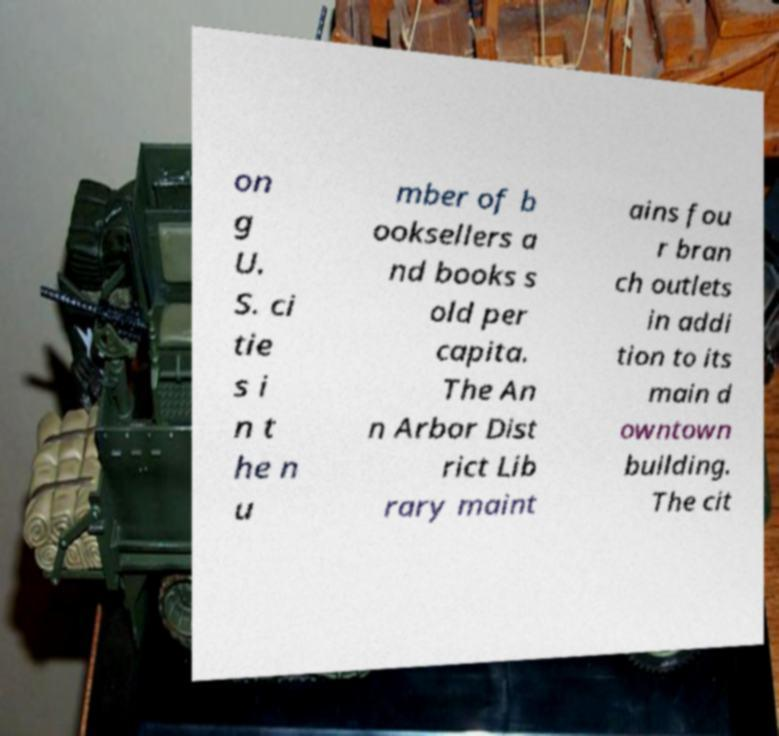Please read and relay the text visible in this image. What does it say? on g U. S. ci tie s i n t he n u mber of b ooksellers a nd books s old per capita. The An n Arbor Dist rict Lib rary maint ains fou r bran ch outlets in addi tion to its main d owntown building. The cit 